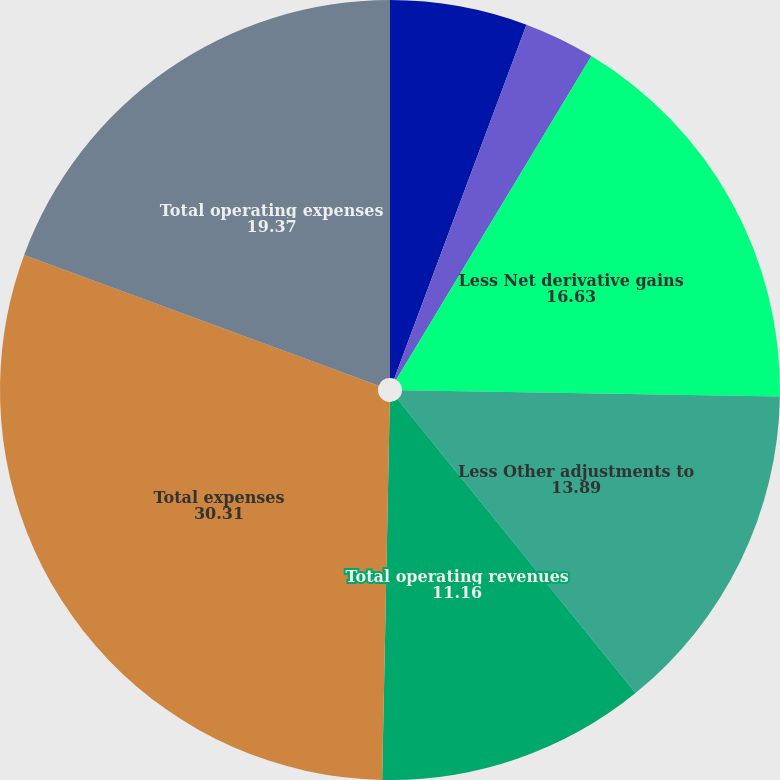<chart> <loc_0><loc_0><loc_500><loc_500><pie_chart><fcel>Total revenues<fcel>Less Net investment gains<fcel>Less Net derivative gains<fcel>Less Other adjustments to<fcel>Total operating revenues<fcel>Total expenses<fcel>Total operating expenses<nl><fcel>5.69%<fcel>2.95%<fcel>16.63%<fcel>13.89%<fcel>11.16%<fcel>30.31%<fcel>19.37%<nl></chart> 